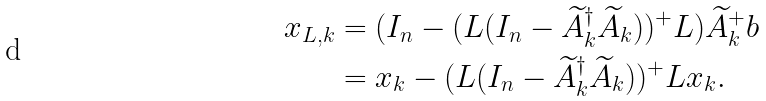<formula> <loc_0><loc_0><loc_500><loc_500>x _ { L , k } & = ( I _ { n } - ( L ( I _ { n } - \widetilde { A } _ { k } ^ { \dagger } \widetilde { A } _ { k } ) ) ^ { + } L ) \widetilde { A } _ { k } ^ { + } b \\ & = x _ { k } - ( L ( I _ { n } - \widetilde { A } _ { k } ^ { \dagger } \widetilde { A } _ { k } ) ) ^ { + } L x _ { k } .</formula> 